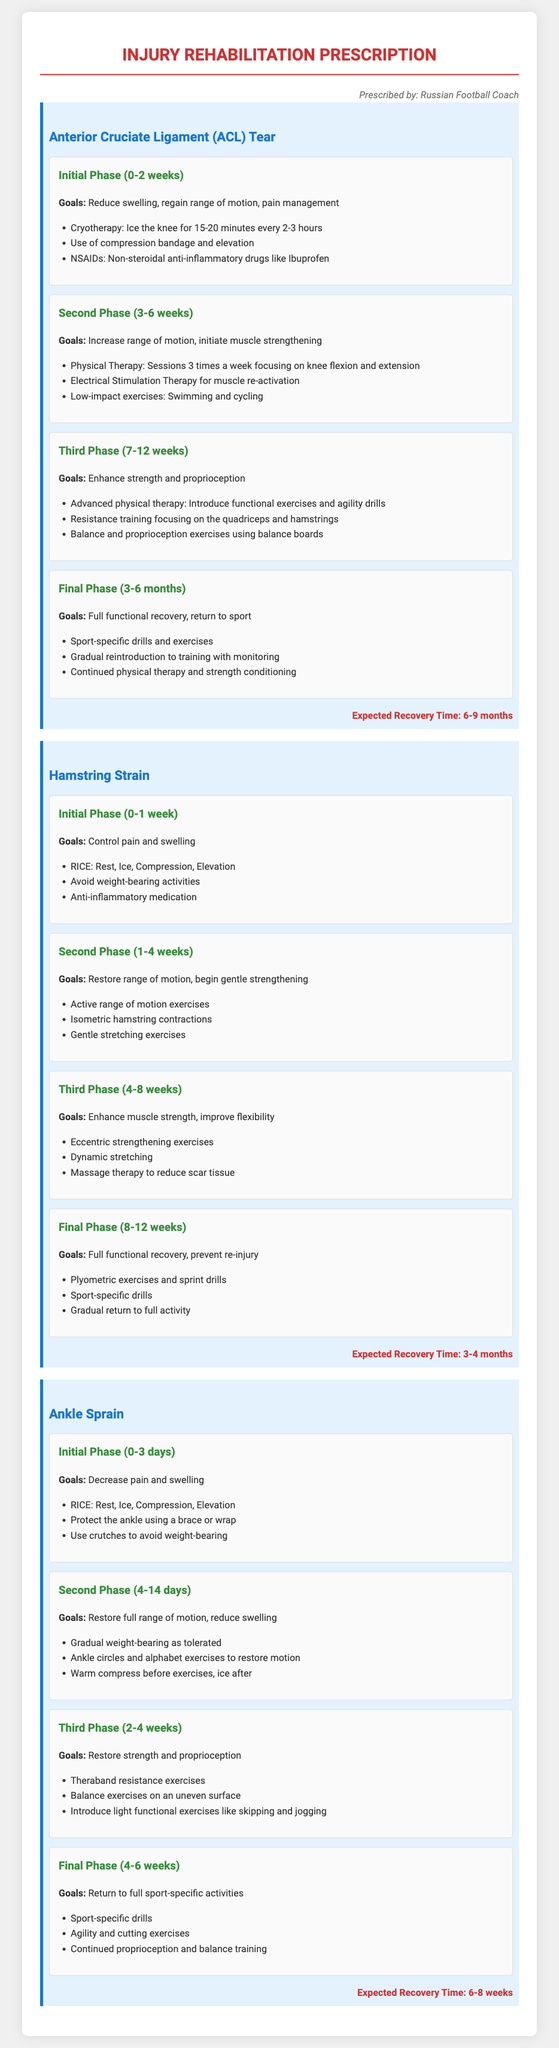What is the expected recovery time for an ACL tear? The expected recovery time is stated in the document as a duration specific to an ACL tear injury.
Answer: 6-9 months What is the goal of the second phase for a hamstring strain? The document outlines specific goals for each phase of recovery, particularly noting goals for the second phase for hamstring strain.
Answer: Restore range of motion, begin gentle strengthening How long does the initial phase last for an ankle sprain? The duration of the initial phase for recovering from an ankle sprain can be found in the rehabilitation prescription.
Answer: 0-3 days What type of therapy is introduced in the third phase for an ACL tear? The document lists various therapies and exercises for each phase, specifically noting the addition of advanced therapy in the third phase for an ACL tear.
Answer: Advanced physical therapy What exercise is recommended in the final phase for an ankle sprain? The document specifies exercises that are sport-specific and aimed at restoring full activity in the final phase of recovery from an ankle sprain.
Answer: Sport-specific drills What pain management technique is suggested in the initial phase for a hamstring strain? Details provided in the prescription include specific techniques for managing pain during the initial phase of a hamstring strain.
Answer: RICE What is the main goal of the final phase for an ACL tear? The document clearly indicates the objectives for the final phase of recovery, focusing specifically on full recovery and readiness for sport.
Answer: Full functional recovery, return to sport What kind of medication is recommended in the initial phase for an ACL tear? The document specifies a type of medication that can be used for pain relief during the initial rehabilitation phase for ACL tear.
Answer: NSAIDs: Non-steroidal anti-inflammatory drugs like Ibuprofen 